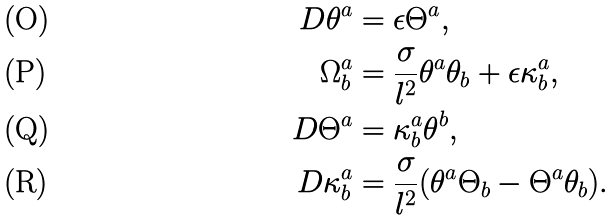Convert formula to latex. <formula><loc_0><loc_0><loc_500><loc_500>D \theta ^ { a } & = \epsilon \Theta ^ { a } , \\ \Omega _ { b } ^ { a } & = \frac { \sigma } { l ^ { 2 } } \theta ^ { a } \theta _ { b } + \epsilon \kappa _ { b } ^ { a } , \\ D \Theta ^ { a } & = \kappa _ { b } ^ { a } \theta ^ { b } , \\ D \kappa _ { b } ^ { a } & = \frac { \sigma } { l ^ { 2 } } ( \theta ^ { a } \Theta _ { b } - \Theta ^ { a } \theta _ { b } ) .</formula> 